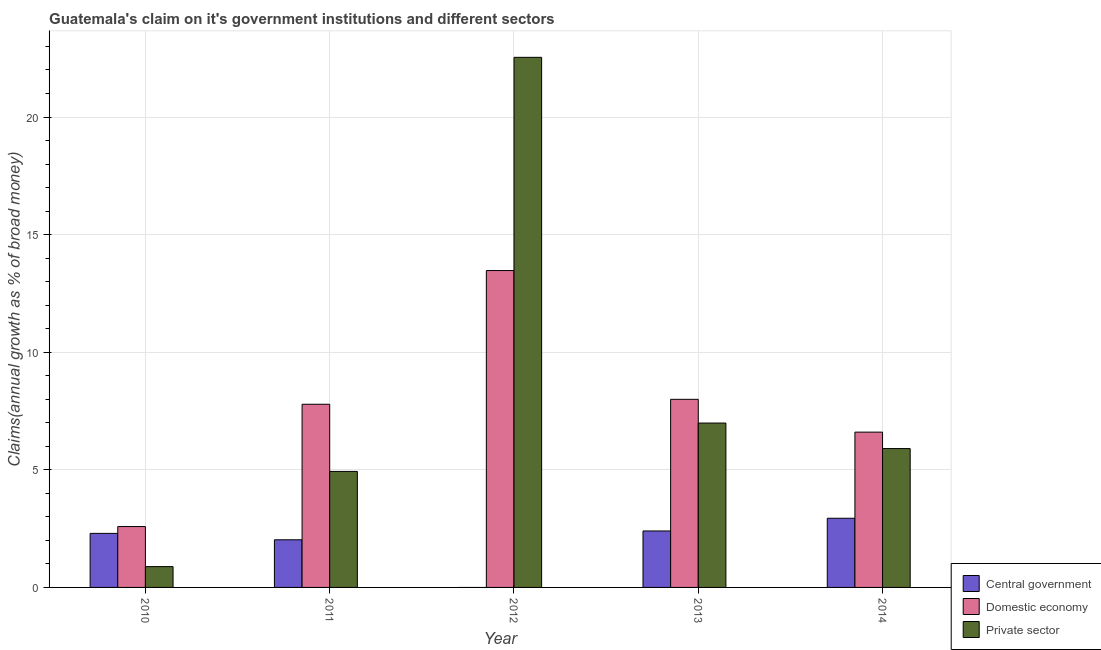How many different coloured bars are there?
Your answer should be compact. 3. How many groups of bars are there?
Your answer should be compact. 5. What is the label of the 4th group of bars from the left?
Offer a terse response. 2013. In how many cases, is the number of bars for a given year not equal to the number of legend labels?
Give a very brief answer. 1. What is the percentage of claim on the private sector in 2010?
Your answer should be compact. 0.88. Across all years, what is the maximum percentage of claim on the central government?
Your answer should be compact. 2.94. Across all years, what is the minimum percentage of claim on the private sector?
Provide a short and direct response. 0.88. In which year was the percentage of claim on the central government maximum?
Offer a very short reply. 2014. What is the total percentage of claim on the central government in the graph?
Your response must be concise. 9.66. What is the difference between the percentage of claim on the central government in 2010 and that in 2011?
Make the answer very short. 0.27. What is the difference between the percentage of claim on the private sector in 2011 and the percentage of claim on the central government in 2012?
Keep it short and to the point. -17.61. What is the average percentage of claim on the private sector per year?
Make the answer very short. 8.25. In the year 2010, what is the difference between the percentage of claim on the central government and percentage of claim on the private sector?
Provide a short and direct response. 0. In how many years, is the percentage of claim on the central government greater than 19 %?
Ensure brevity in your answer.  0. What is the ratio of the percentage of claim on the domestic economy in 2011 to that in 2014?
Provide a short and direct response. 1.18. Is the percentage of claim on the private sector in 2010 less than that in 2011?
Provide a short and direct response. Yes. Is the difference between the percentage of claim on the domestic economy in 2012 and 2013 greater than the difference between the percentage of claim on the private sector in 2012 and 2013?
Keep it short and to the point. No. What is the difference between the highest and the second highest percentage of claim on the domestic economy?
Keep it short and to the point. 5.47. What is the difference between the highest and the lowest percentage of claim on the private sector?
Your response must be concise. 21.65. Is the sum of the percentage of claim on the private sector in 2012 and 2014 greater than the maximum percentage of claim on the domestic economy across all years?
Ensure brevity in your answer.  Yes. Is it the case that in every year, the sum of the percentage of claim on the central government and percentage of claim on the domestic economy is greater than the percentage of claim on the private sector?
Your answer should be compact. No. Are all the bars in the graph horizontal?
Offer a terse response. No. What is the difference between two consecutive major ticks on the Y-axis?
Offer a very short reply. 5. Are the values on the major ticks of Y-axis written in scientific E-notation?
Keep it short and to the point. No. Does the graph contain grids?
Give a very brief answer. Yes. How many legend labels are there?
Provide a succinct answer. 3. How are the legend labels stacked?
Your answer should be very brief. Vertical. What is the title of the graph?
Your answer should be very brief. Guatemala's claim on it's government institutions and different sectors. What is the label or title of the Y-axis?
Your response must be concise. Claims(annual growth as % of broad money). What is the Claims(annual growth as % of broad money) in Central government in 2010?
Your answer should be compact. 2.3. What is the Claims(annual growth as % of broad money) in Domestic economy in 2010?
Provide a short and direct response. 2.59. What is the Claims(annual growth as % of broad money) in Private sector in 2010?
Keep it short and to the point. 0.88. What is the Claims(annual growth as % of broad money) of Central government in 2011?
Your answer should be very brief. 2.03. What is the Claims(annual growth as % of broad money) in Domestic economy in 2011?
Keep it short and to the point. 7.79. What is the Claims(annual growth as % of broad money) in Private sector in 2011?
Ensure brevity in your answer.  4.93. What is the Claims(annual growth as % of broad money) in Central government in 2012?
Keep it short and to the point. 0. What is the Claims(annual growth as % of broad money) of Domestic economy in 2012?
Keep it short and to the point. 13.47. What is the Claims(annual growth as % of broad money) in Private sector in 2012?
Offer a terse response. 22.54. What is the Claims(annual growth as % of broad money) of Central government in 2013?
Provide a short and direct response. 2.4. What is the Claims(annual growth as % of broad money) of Domestic economy in 2013?
Your response must be concise. 8. What is the Claims(annual growth as % of broad money) of Private sector in 2013?
Give a very brief answer. 6.99. What is the Claims(annual growth as % of broad money) in Central government in 2014?
Keep it short and to the point. 2.94. What is the Claims(annual growth as % of broad money) in Domestic economy in 2014?
Provide a succinct answer. 6.6. What is the Claims(annual growth as % of broad money) in Private sector in 2014?
Your answer should be compact. 5.9. Across all years, what is the maximum Claims(annual growth as % of broad money) in Central government?
Give a very brief answer. 2.94. Across all years, what is the maximum Claims(annual growth as % of broad money) in Domestic economy?
Your answer should be compact. 13.47. Across all years, what is the maximum Claims(annual growth as % of broad money) of Private sector?
Your response must be concise. 22.54. Across all years, what is the minimum Claims(annual growth as % of broad money) of Central government?
Your response must be concise. 0. Across all years, what is the minimum Claims(annual growth as % of broad money) in Domestic economy?
Your response must be concise. 2.59. Across all years, what is the minimum Claims(annual growth as % of broad money) in Private sector?
Your response must be concise. 0.88. What is the total Claims(annual growth as % of broad money) in Central government in the graph?
Your answer should be very brief. 9.66. What is the total Claims(annual growth as % of broad money) in Domestic economy in the graph?
Your answer should be compact. 38.45. What is the total Claims(annual growth as % of broad money) in Private sector in the graph?
Your answer should be compact. 41.25. What is the difference between the Claims(annual growth as % of broad money) in Central government in 2010 and that in 2011?
Keep it short and to the point. 0.27. What is the difference between the Claims(annual growth as % of broad money) in Domestic economy in 2010 and that in 2011?
Make the answer very short. -5.2. What is the difference between the Claims(annual growth as % of broad money) of Private sector in 2010 and that in 2011?
Keep it short and to the point. -4.05. What is the difference between the Claims(annual growth as % of broad money) in Domestic economy in 2010 and that in 2012?
Your answer should be compact. -10.88. What is the difference between the Claims(annual growth as % of broad money) in Private sector in 2010 and that in 2012?
Your answer should be compact. -21.65. What is the difference between the Claims(annual growth as % of broad money) in Central government in 2010 and that in 2013?
Give a very brief answer. -0.1. What is the difference between the Claims(annual growth as % of broad money) of Domestic economy in 2010 and that in 2013?
Ensure brevity in your answer.  -5.41. What is the difference between the Claims(annual growth as % of broad money) in Private sector in 2010 and that in 2013?
Your answer should be very brief. -6.1. What is the difference between the Claims(annual growth as % of broad money) of Central government in 2010 and that in 2014?
Keep it short and to the point. -0.64. What is the difference between the Claims(annual growth as % of broad money) in Domestic economy in 2010 and that in 2014?
Provide a short and direct response. -4.01. What is the difference between the Claims(annual growth as % of broad money) of Private sector in 2010 and that in 2014?
Give a very brief answer. -5.02. What is the difference between the Claims(annual growth as % of broad money) in Domestic economy in 2011 and that in 2012?
Your answer should be very brief. -5.68. What is the difference between the Claims(annual growth as % of broad money) of Private sector in 2011 and that in 2012?
Keep it short and to the point. -17.61. What is the difference between the Claims(annual growth as % of broad money) in Central government in 2011 and that in 2013?
Ensure brevity in your answer.  -0.38. What is the difference between the Claims(annual growth as % of broad money) of Domestic economy in 2011 and that in 2013?
Make the answer very short. -0.21. What is the difference between the Claims(annual growth as % of broad money) in Private sector in 2011 and that in 2013?
Ensure brevity in your answer.  -2.06. What is the difference between the Claims(annual growth as % of broad money) in Central government in 2011 and that in 2014?
Your answer should be compact. -0.92. What is the difference between the Claims(annual growth as % of broad money) of Domestic economy in 2011 and that in 2014?
Keep it short and to the point. 1.19. What is the difference between the Claims(annual growth as % of broad money) of Private sector in 2011 and that in 2014?
Ensure brevity in your answer.  -0.97. What is the difference between the Claims(annual growth as % of broad money) of Domestic economy in 2012 and that in 2013?
Your response must be concise. 5.47. What is the difference between the Claims(annual growth as % of broad money) of Private sector in 2012 and that in 2013?
Offer a terse response. 15.55. What is the difference between the Claims(annual growth as % of broad money) in Domestic economy in 2012 and that in 2014?
Give a very brief answer. 6.87. What is the difference between the Claims(annual growth as % of broad money) in Private sector in 2012 and that in 2014?
Your answer should be compact. 16.63. What is the difference between the Claims(annual growth as % of broad money) of Central government in 2013 and that in 2014?
Offer a terse response. -0.54. What is the difference between the Claims(annual growth as % of broad money) in Domestic economy in 2013 and that in 2014?
Keep it short and to the point. 1.39. What is the difference between the Claims(annual growth as % of broad money) in Private sector in 2013 and that in 2014?
Provide a short and direct response. 1.08. What is the difference between the Claims(annual growth as % of broad money) of Central government in 2010 and the Claims(annual growth as % of broad money) of Domestic economy in 2011?
Offer a very short reply. -5.49. What is the difference between the Claims(annual growth as % of broad money) of Central government in 2010 and the Claims(annual growth as % of broad money) of Private sector in 2011?
Offer a terse response. -2.63. What is the difference between the Claims(annual growth as % of broad money) in Domestic economy in 2010 and the Claims(annual growth as % of broad money) in Private sector in 2011?
Offer a very short reply. -2.34. What is the difference between the Claims(annual growth as % of broad money) of Central government in 2010 and the Claims(annual growth as % of broad money) of Domestic economy in 2012?
Your answer should be very brief. -11.17. What is the difference between the Claims(annual growth as % of broad money) of Central government in 2010 and the Claims(annual growth as % of broad money) of Private sector in 2012?
Keep it short and to the point. -20.24. What is the difference between the Claims(annual growth as % of broad money) of Domestic economy in 2010 and the Claims(annual growth as % of broad money) of Private sector in 2012?
Your answer should be compact. -19.95. What is the difference between the Claims(annual growth as % of broad money) of Central government in 2010 and the Claims(annual growth as % of broad money) of Domestic economy in 2013?
Ensure brevity in your answer.  -5.7. What is the difference between the Claims(annual growth as % of broad money) of Central government in 2010 and the Claims(annual growth as % of broad money) of Private sector in 2013?
Offer a very short reply. -4.69. What is the difference between the Claims(annual growth as % of broad money) in Domestic economy in 2010 and the Claims(annual growth as % of broad money) in Private sector in 2013?
Provide a succinct answer. -4.4. What is the difference between the Claims(annual growth as % of broad money) in Central government in 2010 and the Claims(annual growth as % of broad money) in Domestic economy in 2014?
Give a very brief answer. -4.3. What is the difference between the Claims(annual growth as % of broad money) of Central government in 2010 and the Claims(annual growth as % of broad money) of Private sector in 2014?
Keep it short and to the point. -3.61. What is the difference between the Claims(annual growth as % of broad money) in Domestic economy in 2010 and the Claims(annual growth as % of broad money) in Private sector in 2014?
Provide a succinct answer. -3.32. What is the difference between the Claims(annual growth as % of broad money) in Central government in 2011 and the Claims(annual growth as % of broad money) in Domestic economy in 2012?
Your answer should be very brief. -11.45. What is the difference between the Claims(annual growth as % of broad money) of Central government in 2011 and the Claims(annual growth as % of broad money) of Private sector in 2012?
Give a very brief answer. -20.51. What is the difference between the Claims(annual growth as % of broad money) of Domestic economy in 2011 and the Claims(annual growth as % of broad money) of Private sector in 2012?
Your answer should be compact. -14.75. What is the difference between the Claims(annual growth as % of broad money) in Central government in 2011 and the Claims(annual growth as % of broad money) in Domestic economy in 2013?
Your answer should be compact. -5.97. What is the difference between the Claims(annual growth as % of broad money) in Central government in 2011 and the Claims(annual growth as % of broad money) in Private sector in 2013?
Offer a very short reply. -4.96. What is the difference between the Claims(annual growth as % of broad money) of Domestic economy in 2011 and the Claims(annual growth as % of broad money) of Private sector in 2013?
Keep it short and to the point. 0.8. What is the difference between the Claims(annual growth as % of broad money) of Central government in 2011 and the Claims(annual growth as % of broad money) of Domestic economy in 2014?
Offer a terse response. -4.58. What is the difference between the Claims(annual growth as % of broad money) of Central government in 2011 and the Claims(annual growth as % of broad money) of Private sector in 2014?
Offer a terse response. -3.88. What is the difference between the Claims(annual growth as % of broad money) of Domestic economy in 2011 and the Claims(annual growth as % of broad money) of Private sector in 2014?
Your response must be concise. 1.88. What is the difference between the Claims(annual growth as % of broad money) of Domestic economy in 2012 and the Claims(annual growth as % of broad money) of Private sector in 2013?
Keep it short and to the point. 6.48. What is the difference between the Claims(annual growth as % of broad money) of Domestic economy in 2012 and the Claims(annual growth as % of broad money) of Private sector in 2014?
Your response must be concise. 7.57. What is the difference between the Claims(annual growth as % of broad money) in Central government in 2013 and the Claims(annual growth as % of broad money) in Domestic economy in 2014?
Provide a short and direct response. -4.2. What is the difference between the Claims(annual growth as % of broad money) of Central government in 2013 and the Claims(annual growth as % of broad money) of Private sector in 2014?
Provide a short and direct response. -3.5. What is the difference between the Claims(annual growth as % of broad money) in Domestic economy in 2013 and the Claims(annual growth as % of broad money) in Private sector in 2014?
Provide a succinct answer. 2.09. What is the average Claims(annual growth as % of broad money) in Central government per year?
Your answer should be very brief. 1.93. What is the average Claims(annual growth as % of broad money) in Domestic economy per year?
Provide a succinct answer. 7.69. What is the average Claims(annual growth as % of broad money) in Private sector per year?
Provide a short and direct response. 8.25. In the year 2010, what is the difference between the Claims(annual growth as % of broad money) of Central government and Claims(annual growth as % of broad money) of Domestic economy?
Offer a very short reply. -0.29. In the year 2010, what is the difference between the Claims(annual growth as % of broad money) of Central government and Claims(annual growth as % of broad money) of Private sector?
Make the answer very short. 1.41. In the year 2010, what is the difference between the Claims(annual growth as % of broad money) in Domestic economy and Claims(annual growth as % of broad money) in Private sector?
Make the answer very short. 1.7. In the year 2011, what is the difference between the Claims(annual growth as % of broad money) of Central government and Claims(annual growth as % of broad money) of Domestic economy?
Keep it short and to the point. -5.76. In the year 2011, what is the difference between the Claims(annual growth as % of broad money) in Central government and Claims(annual growth as % of broad money) in Private sector?
Give a very brief answer. -2.91. In the year 2011, what is the difference between the Claims(annual growth as % of broad money) of Domestic economy and Claims(annual growth as % of broad money) of Private sector?
Make the answer very short. 2.86. In the year 2012, what is the difference between the Claims(annual growth as % of broad money) of Domestic economy and Claims(annual growth as % of broad money) of Private sector?
Ensure brevity in your answer.  -9.07. In the year 2013, what is the difference between the Claims(annual growth as % of broad money) of Central government and Claims(annual growth as % of broad money) of Domestic economy?
Make the answer very short. -5.6. In the year 2013, what is the difference between the Claims(annual growth as % of broad money) of Central government and Claims(annual growth as % of broad money) of Private sector?
Your answer should be compact. -4.59. In the year 2013, what is the difference between the Claims(annual growth as % of broad money) of Domestic economy and Claims(annual growth as % of broad money) of Private sector?
Keep it short and to the point. 1.01. In the year 2014, what is the difference between the Claims(annual growth as % of broad money) in Central government and Claims(annual growth as % of broad money) in Domestic economy?
Make the answer very short. -3.66. In the year 2014, what is the difference between the Claims(annual growth as % of broad money) in Central government and Claims(annual growth as % of broad money) in Private sector?
Your answer should be very brief. -2.96. In the year 2014, what is the difference between the Claims(annual growth as % of broad money) in Domestic economy and Claims(annual growth as % of broad money) in Private sector?
Keep it short and to the point. 0.7. What is the ratio of the Claims(annual growth as % of broad money) of Central government in 2010 to that in 2011?
Your response must be concise. 1.13. What is the ratio of the Claims(annual growth as % of broad money) in Domestic economy in 2010 to that in 2011?
Offer a terse response. 0.33. What is the ratio of the Claims(annual growth as % of broad money) in Private sector in 2010 to that in 2011?
Offer a terse response. 0.18. What is the ratio of the Claims(annual growth as % of broad money) of Domestic economy in 2010 to that in 2012?
Make the answer very short. 0.19. What is the ratio of the Claims(annual growth as % of broad money) of Private sector in 2010 to that in 2012?
Your answer should be very brief. 0.04. What is the ratio of the Claims(annual growth as % of broad money) in Central government in 2010 to that in 2013?
Offer a very short reply. 0.96. What is the ratio of the Claims(annual growth as % of broad money) in Domestic economy in 2010 to that in 2013?
Your response must be concise. 0.32. What is the ratio of the Claims(annual growth as % of broad money) of Private sector in 2010 to that in 2013?
Provide a succinct answer. 0.13. What is the ratio of the Claims(annual growth as % of broad money) of Central government in 2010 to that in 2014?
Keep it short and to the point. 0.78. What is the ratio of the Claims(annual growth as % of broad money) in Domestic economy in 2010 to that in 2014?
Your answer should be compact. 0.39. What is the ratio of the Claims(annual growth as % of broad money) in Private sector in 2010 to that in 2014?
Your answer should be very brief. 0.15. What is the ratio of the Claims(annual growth as % of broad money) of Domestic economy in 2011 to that in 2012?
Keep it short and to the point. 0.58. What is the ratio of the Claims(annual growth as % of broad money) in Private sector in 2011 to that in 2012?
Make the answer very short. 0.22. What is the ratio of the Claims(annual growth as % of broad money) in Central government in 2011 to that in 2013?
Ensure brevity in your answer.  0.84. What is the ratio of the Claims(annual growth as % of broad money) of Domestic economy in 2011 to that in 2013?
Ensure brevity in your answer.  0.97. What is the ratio of the Claims(annual growth as % of broad money) in Private sector in 2011 to that in 2013?
Give a very brief answer. 0.71. What is the ratio of the Claims(annual growth as % of broad money) in Central government in 2011 to that in 2014?
Provide a succinct answer. 0.69. What is the ratio of the Claims(annual growth as % of broad money) of Domestic economy in 2011 to that in 2014?
Offer a very short reply. 1.18. What is the ratio of the Claims(annual growth as % of broad money) in Private sector in 2011 to that in 2014?
Give a very brief answer. 0.84. What is the ratio of the Claims(annual growth as % of broad money) of Domestic economy in 2012 to that in 2013?
Give a very brief answer. 1.68. What is the ratio of the Claims(annual growth as % of broad money) of Private sector in 2012 to that in 2013?
Offer a terse response. 3.23. What is the ratio of the Claims(annual growth as % of broad money) in Domestic economy in 2012 to that in 2014?
Your answer should be compact. 2.04. What is the ratio of the Claims(annual growth as % of broad money) in Private sector in 2012 to that in 2014?
Keep it short and to the point. 3.82. What is the ratio of the Claims(annual growth as % of broad money) in Central government in 2013 to that in 2014?
Your answer should be compact. 0.82. What is the ratio of the Claims(annual growth as % of broad money) of Domestic economy in 2013 to that in 2014?
Offer a terse response. 1.21. What is the ratio of the Claims(annual growth as % of broad money) of Private sector in 2013 to that in 2014?
Ensure brevity in your answer.  1.18. What is the difference between the highest and the second highest Claims(annual growth as % of broad money) of Central government?
Keep it short and to the point. 0.54. What is the difference between the highest and the second highest Claims(annual growth as % of broad money) of Domestic economy?
Ensure brevity in your answer.  5.47. What is the difference between the highest and the second highest Claims(annual growth as % of broad money) in Private sector?
Your answer should be very brief. 15.55. What is the difference between the highest and the lowest Claims(annual growth as % of broad money) in Central government?
Your answer should be very brief. 2.94. What is the difference between the highest and the lowest Claims(annual growth as % of broad money) of Domestic economy?
Ensure brevity in your answer.  10.88. What is the difference between the highest and the lowest Claims(annual growth as % of broad money) of Private sector?
Your response must be concise. 21.65. 